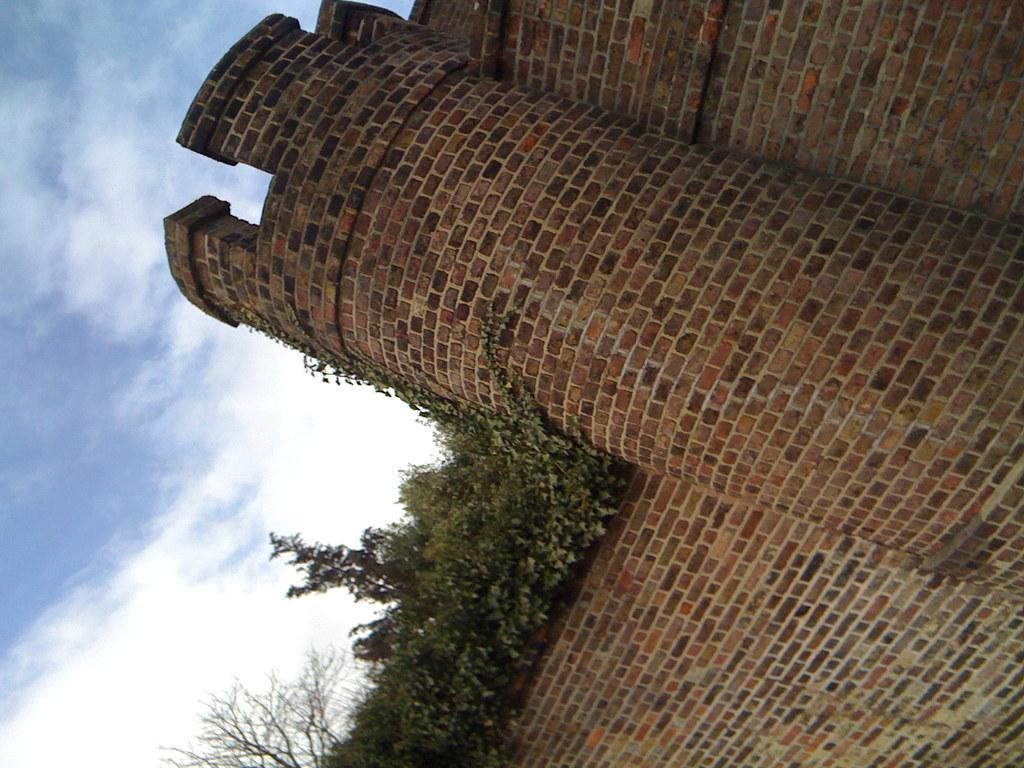What type of structure is visible in the image? There is a building in the image. What other natural elements can be seen in the image? There are trees in the image. How would you describe the weather based on the sky in the image? The sky is cloudy in the image. What type of boundary can be seen in the image? There is no boundary visible in the image; it features a building, trees, and a cloudy sky. Can you tell me when the birth of the trees in the image occurred? The image does not provide information about the birth of the trees; it only shows their current state. 